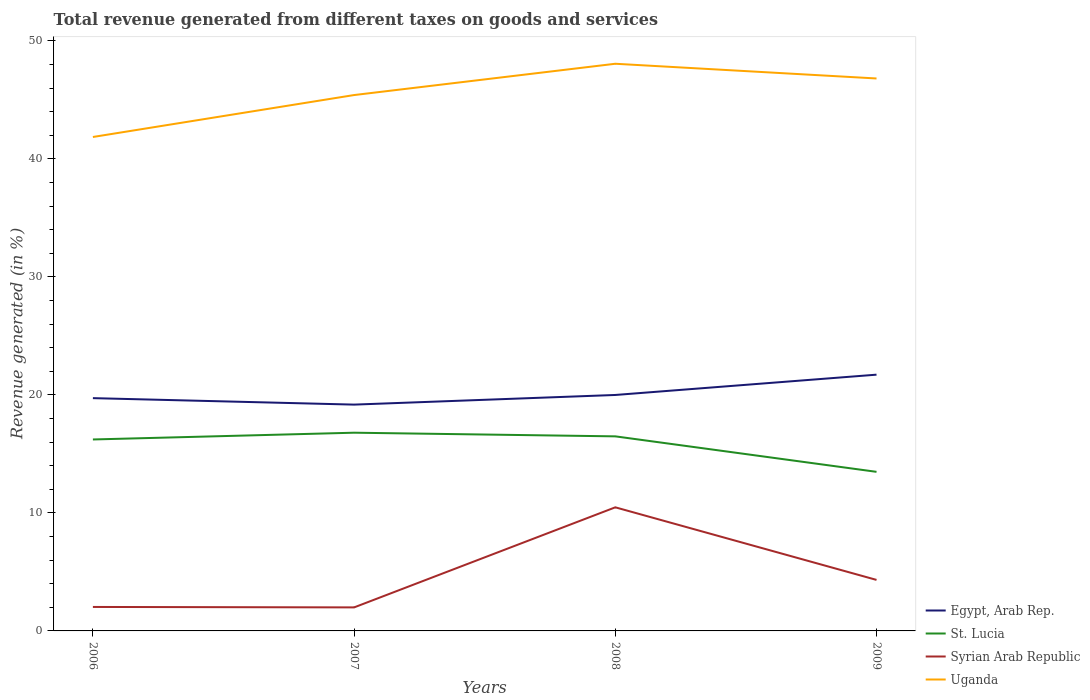Does the line corresponding to Uganda intersect with the line corresponding to Egypt, Arab Rep.?
Offer a terse response. No. Is the number of lines equal to the number of legend labels?
Your response must be concise. Yes. Across all years, what is the maximum total revenue generated in Syrian Arab Republic?
Make the answer very short. 1.99. In which year was the total revenue generated in Syrian Arab Republic maximum?
Give a very brief answer. 2007. What is the total total revenue generated in Syrian Arab Republic in the graph?
Provide a short and direct response. -8.48. What is the difference between the highest and the second highest total revenue generated in Egypt, Arab Rep.?
Make the answer very short. 2.54. What is the difference between the highest and the lowest total revenue generated in St. Lucia?
Ensure brevity in your answer.  3. How many lines are there?
Your response must be concise. 4. How many years are there in the graph?
Offer a terse response. 4. Does the graph contain any zero values?
Ensure brevity in your answer.  No. Where does the legend appear in the graph?
Give a very brief answer. Bottom right. How many legend labels are there?
Make the answer very short. 4. How are the legend labels stacked?
Your response must be concise. Vertical. What is the title of the graph?
Your answer should be very brief. Total revenue generated from different taxes on goods and services. Does "Hungary" appear as one of the legend labels in the graph?
Your answer should be compact. No. What is the label or title of the X-axis?
Provide a succinct answer. Years. What is the label or title of the Y-axis?
Provide a succinct answer. Revenue generated (in %). What is the Revenue generated (in %) of Egypt, Arab Rep. in 2006?
Ensure brevity in your answer.  19.72. What is the Revenue generated (in %) in St. Lucia in 2006?
Your response must be concise. 16.22. What is the Revenue generated (in %) in Syrian Arab Republic in 2006?
Provide a short and direct response. 2.03. What is the Revenue generated (in %) of Uganda in 2006?
Keep it short and to the point. 41.85. What is the Revenue generated (in %) in Egypt, Arab Rep. in 2007?
Offer a terse response. 19.18. What is the Revenue generated (in %) in St. Lucia in 2007?
Give a very brief answer. 16.8. What is the Revenue generated (in %) in Syrian Arab Republic in 2007?
Make the answer very short. 1.99. What is the Revenue generated (in %) of Uganda in 2007?
Make the answer very short. 45.4. What is the Revenue generated (in %) in Egypt, Arab Rep. in 2008?
Provide a succinct answer. 19.99. What is the Revenue generated (in %) of St. Lucia in 2008?
Your response must be concise. 16.49. What is the Revenue generated (in %) in Syrian Arab Republic in 2008?
Your answer should be compact. 10.47. What is the Revenue generated (in %) of Uganda in 2008?
Offer a very short reply. 48.06. What is the Revenue generated (in %) of Egypt, Arab Rep. in 2009?
Provide a succinct answer. 21.71. What is the Revenue generated (in %) of St. Lucia in 2009?
Provide a succinct answer. 13.48. What is the Revenue generated (in %) in Syrian Arab Republic in 2009?
Give a very brief answer. 4.32. What is the Revenue generated (in %) of Uganda in 2009?
Keep it short and to the point. 46.81. Across all years, what is the maximum Revenue generated (in %) in Egypt, Arab Rep.?
Provide a succinct answer. 21.71. Across all years, what is the maximum Revenue generated (in %) of St. Lucia?
Your answer should be compact. 16.8. Across all years, what is the maximum Revenue generated (in %) in Syrian Arab Republic?
Your answer should be very brief. 10.47. Across all years, what is the maximum Revenue generated (in %) in Uganda?
Ensure brevity in your answer.  48.06. Across all years, what is the minimum Revenue generated (in %) in Egypt, Arab Rep.?
Offer a very short reply. 19.18. Across all years, what is the minimum Revenue generated (in %) in St. Lucia?
Give a very brief answer. 13.48. Across all years, what is the minimum Revenue generated (in %) of Syrian Arab Republic?
Ensure brevity in your answer.  1.99. Across all years, what is the minimum Revenue generated (in %) of Uganda?
Provide a succinct answer. 41.85. What is the total Revenue generated (in %) of Egypt, Arab Rep. in the graph?
Your answer should be compact. 80.6. What is the total Revenue generated (in %) in St. Lucia in the graph?
Offer a terse response. 62.98. What is the total Revenue generated (in %) in Syrian Arab Republic in the graph?
Your answer should be very brief. 18.82. What is the total Revenue generated (in %) in Uganda in the graph?
Provide a succinct answer. 182.12. What is the difference between the Revenue generated (in %) in Egypt, Arab Rep. in 2006 and that in 2007?
Offer a terse response. 0.55. What is the difference between the Revenue generated (in %) of St. Lucia in 2006 and that in 2007?
Your answer should be very brief. -0.57. What is the difference between the Revenue generated (in %) of Syrian Arab Republic in 2006 and that in 2007?
Keep it short and to the point. 0.04. What is the difference between the Revenue generated (in %) of Uganda in 2006 and that in 2007?
Offer a terse response. -3.55. What is the difference between the Revenue generated (in %) of Egypt, Arab Rep. in 2006 and that in 2008?
Give a very brief answer. -0.27. What is the difference between the Revenue generated (in %) of St. Lucia in 2006 and that in 2008?
Provide a succinct answer. -0.26. What is the difference between the Revenue generated (in %) in Syrian Arab Republic in 2006 and that in 2008?
Make the answer very short. -8.44. What is the difference between the Revenue generated (in %) of Uganda in 2006 and that in 2008?
Your answer should be very brief. -6.2. What is the difference between the Revenue generated (in %) in Egypt, Arab Rep. in 2006 and that in 2009?
Give a very brief answer. -1.99. What is the difference between the Revenue generated (in %) in St. Lucia in 2006 and that in 2009?
Provide a short and direct response. 2.74. What is the difference between the Revenue generated (in %) in Syrian Arab Republic in 2006 and that in 2009?
Provide a short and direct response. -2.29. What is the difference between the Revenue generated (in %) of Uganda in 2006 and that in 2009?
Make the answer very short. -4.96. What is the difference between the Revenue generated (in %) of Egypt, Arab Rep. in 2007 and that in 2008?
Give a very brief answer. -0.82. What is the difference between the Revenue generated (in %) of St. Lucia in 2007 and that in 2008?
Provide a succinct answer. 0.31. What is the difference between the Revenue generated (in %) in Syrian Arab Republic in 2007 and that in 2008?
Make the answer very short. -8.48. What is the difference between the Revenue generated (in %) of Uganda in 2007 and that in 2008?
Offer a terse response. -2.65. What is the difference between the Revenue generated (in %) in Egypt, Arab Rep. in 2007 and that in 2009?
Provide a short and direct response. -2.54. What is the difference between the Revenue generated (in %) of St. Lucia in 2007 and that in 2009?
Offer a very short reply. 3.32. What is the difference between the Revenue generated (in %) of Syrian Arab Republic in 2007 and that in 2009?
Provide a short and direct response. -2.33. What is the difference between the Revenue generated (in %) in Uganda in 2007 and that in 2009?
Provide a short and direct response. -1.4. What is the difference between the Revenue generated (in %) in Egypt, Arab Rep. in 2008 and that in 2009?
Your answer should be compact. -1.72. What is the difference between the Revenue generated (in %) in St. Lucia in 2008 and that in 2009?
Keep it short and to the point. 3.01. What is the difference between the Revenue generated (in %) of Syrian Arab Republic in 2008 and that in 2009?
Your response must be concise. 6.15. What is the difference between the Revenue generated (in %) in Uganda in 2008 and that in 2009?
Make the answer very short. 1.25. What is the difference between the Revenue generated (in %) of Egypt, Arab Rep. in 2006 and the Revenue generated (in %) of St. Lucia in 2007?
Give a very brief answer. 2.93. What is the difference between the Revenue generated (in %) of Egypt, Arab Rep. in 2006 and the Revenue generated (in %) of Syrian Arab Republic in 2007?
Offer a terse response. 17.73. What is the difference between the Revenue generated (in %) in Egypt, Arab Rep. in 2006 and the Revenue generated (in %) in Uganda in 2007?
Provide a short and direct response. -25.68. What is the difference between the Revenue generated (in %) of St. Lucia in 2006 and the Revenue generated (in %) of Syrian Arab Republic in 2007?
Make the answer very short. 14.23. What is the difference between the Revenue generated (in %) of St. Lucia in 2006 and the Revenue generated (in %) of Uganda in 2007?
Your answer should be very brief. -29.18. What is the difference between the Revenue generated (in %) in Syrian Arab Republic in 2006 and the Revenue generated (in %) in Uganda in 2007?
Offer a terse response. -43.37. What is the difference between the Revenue generated (in %) in Egypt, Arab Rep. in 2006 and the Revenue generated (in %) in St. Lucia in 2008?
Provide a succinct answer. 3.24. What is the difference between the Revenue generated (in %) of Egypt, Arab Rep. in 2006 and the Revenue generated (in %) of Syrian Arab Republic in 2008?
Your answer should be very brief. 9.25. What is the difference between the Revenue generated (in %) of Egypt, Arab Rep. in 2006 and the Revenue generated (in %) of Uganda in 2008?
Provide a short and direct response. -28.33. What is the difference between the Revenue generated (in %) in St. Lucia in 2006 and the Revenue generated (in %) in Syrian Arab Republic in 2008?
Offer a very short reply. 5.75. What is the difference between the Revenue generated (in %) in St. Lucia in 2006 and the Revenue generated (in %) in Uganda in 2008?
Your response must be concise. -31.83. What is the difference between the Revenue generated (in %) in Syrian Arab Republic in 2006 and the Revenue generated (in %) in Uganda in 2008?
Your answer should be compact. -46.02. What is the difference between the Revenue generated (in %) in Egypt, Arab Rep. in 2006 and the Revenue generated (in %) in St. Lucia in 2009?
Ensure brevity in your answer.  6.24. What is the difference between the Revenue generated (in %) of Egypt, Arab Rep. in 2006 and the Revenue generated (in %) of Syrian Arab Republic in 2009?
Offer a very short reply. 15.4. What is the difference between the Revenue generated (in %) of Egypt, Arab Rep. in 2006 and the Revenue generated (in %) of Uganda in 2009?
Make the answer very short. -27.09. What is the difference between the Revenue generated (in %) in St. Lucia in 2006 and the Revenue generated (in %) in Syrian Arab Republic in 2009?
Your answer should be very brief. 11.9. What is the difference between the Revenue generated (in %) in St. Lucia in 2006 and the Revenue generated (in %) in Uganda in 2009?
Your answer should be very brief. -30.59. What is the difference between the Revenue generated (in %) in Syrian Arab Republic in 2006 and the Revenue generated (in %) in Uganda in 2009?
Your response must be concise. -44.78. What is the difference between the Revenue generated (in %) in Egypt, Arab Rep. in 2007 and the Revenue generated (in %) in St. Lucia in 2008?
Ensure brevity in your answer.  2.69. What is the difference between the Revenue generated (in %) of Egypt, Arab Rep. in 2007 and the Revenue generated (in %) of Syrian Arab Republic in 2008?
Ensure brevity in your answer.  8.7. What is the difference between the Revenue generated (in %) of Egypt, Arab Rep. in 2007 and the Revenue generated (in %) of Uganda in 2008?
Give a very brief answer. -28.88. What is the difference between the Revenue generated (in %) of St. Lucia in 2007 and the Revenue generated (in %) of Syrian Arab Republic in 2008?
Give a very brief answer. 6.32. What is the difference between the Revenue generated (in %) in St. Lucia in 2007 and the Revenue generated (in %) in Uganda in 2008?
Your response must be concise. -31.26. What is the difference between the Revenue generated (in %) of Syrian Arab Republic in 2007 and the Revenue generated (in %) of Uganda in 2008?
Your answer should be compact. -46.06. What is the difference between the Revenue generated (in %) in Egypt, Arab Rep. in 2007 and the Revenue generated (in %) in St. Lucia in 2009?
Make the answer very short. 5.7. What is the difference between the Revenue generated (in %) in Egypt, Arab Rep. in 2007 and the Revenue generated (in %) in Syrian Arab Republic in 2009?
Offer a terse response. 14.85. What is the difference between the Revenue generated (in %) in Egypt, Arab Rep. in 2007 and the Revenue generated (in %) in Uganda in 2009?
Your response must be concise. -27.63. What is the difference between the Revenue generated (in %) of St. Lucia in 2007 and the Revenue generated (in %) of Syrian Arab Republic in 2009?
Ensure brevity in your answer.  12.47. What is the difference between the Revenue generated (in %) of St. Lucia in 2007 and the Revenue generated (in %) of Uganda in 2009?
Make the answer very short. -30.01. What is the difference between the Revenue generated (in %) in Syrian Arab Republic in 2007 and the Revenue generated (in %) in Uganda in 2009?
Offer a terse response. -44.82. What is the difference between the Revenue generated (in %) of Egypt, Arab Rep. in 2008 and the Revenue generated (in %) of St. Lucia in 2009?
Provide a short and direct response. 6.51. What is the difference between the Revenue generated (in %) in Egypt, Arab Rep. in 2008 and the Revenue generated (in %) in Syrian Arab Republic in 2009?
Ensure brevity in your answer.  15.67. What is the difference between the Revenue generated (in %) in Egypt, Arab Rep. in 2008 and the Revenue generated (in %) in Uganda in 2009?
Ensure brevity in your answer.  -26.82. What is the difference between the Revenue generated (in %) in St. Lucia in 2008 and the Revenue generated (in %) in Syrian Arab Republic in 2009?
Offer a terse response. 12.16. What is the difference between the Revenue generated (in %) of St. Lucia in 2008 and the Revenue generated (in %) of Uganda in 2009?
Keep it short and to the point. -30.32. What is the difference between the Revenue generated (in %) of Syrian Arab Republic in 2008 and the Revenue generated (in %) of Uganda in 2009?
Offer a very short reply. -36.34. What is the average Revenue generated (in %) in Egypt, Arab Rep. per year?
Provide a short and direct response. 20.15. What is the average Revenue generated (in %) in St. Lucia per year?
Offer a very short reply. 15.75. What is the average Revenue generated (in %) of Syrian Arab Republic per year?
Offer a terse response. 4.7. What is the average Revenue generated (in %) of Uganda per year?
Offer a very short reply. 45.53. In the year 2006, what is the difference between the Revenue generated (in %) in Egypt, Arab Rep. and Revenue generated (in %) in St. Lucia?
Offer a very short reply. 3.5. In the year 2006, what is the difference between the Revenue generated (in %) in Egypt, Arab Rep. and Revenue generated (in %) in Syrian Arab Republic?
Keep it short and to the point. 17.69. In the year 2006, what is the difference between the Revenue generated (in %) of Egypt, Arab Rep. and Revenue generated (in %) of Uganda?
Provide a succinct answer. -22.13. In the year 2006, what is the difference between the Revenue generated (in %) of St. Lucia and Revenue generated (in %) of Syrian Arab Republic?
Provide a succinct answer. 14.19. In the year 2006, what is the difference between the Revenue generated (in %) of St. Lucia and Revenue generated (in %) of Uganda?
Offer a very short reply. -25.63. In the year 2006, what is the difference between the Revenue generated (in %) of Syrian Arab Republic and Revenue generated (in %) of Uganda?
Your response must be concise. -39.82. In the year 2007, what is the difference between the Revenue generated (in %) in Egypt, Arab Rep. and Revenue generated (in %) in St. Lucia?
Keep it short and to the point. 2.38. In the year 2007, what is the difference between the Revenue generated (in %) in Egypt, Arab Rep. and Revenue generated (in %) in Syrian Arab Republic?
Offer a very short reply. 17.18. In the year 2007, what is the difference between the Revenue generated (in %) in Egypt, Arab Rep. and Revenue generated (in %) in Uganda?
Give a very brief answer. -26.23. In the year 2007, what is the difference between the Revenue generated (in %) of St. Lucia and Revenue generated (in %) of Syrian Arab Republic?
Ensure brevity in your answer.  14.8. In the year 2007, what is the difference between the Revenue generated (in %) of St. Lucia and Revenue generated (in %) of Uganda?
Provide a short and direct response. -28.61. In the year 2007, what is the difference between the Revenue generated (in %) in Syrian Arab Republic and Revenue generated (in %) in Uganda?
Offer a terse response. -43.41. In the year 2008, what is the difference between the Revenue generated (in %) of Egypt, Arab Rep. and Revenue generated (in %) of St. Lucia?
Your response must be concise. 3.51. In the year 2008, what is the difference between the Revenue generated (in %) in Egypt, Arab Rep. and Revenue generated (in %) in Syrian Arab Republic?
Provide a short and direct response. 9.52. In the year 2008, what is the difference between the Revenue generated (in %) of Egypt, Arab Rep. and Revenue generated (in %) of Uganda?
Give a very brief answer. -28.06. In the year 2008, what is the difference between the Revenue generated (in %) in St. Lucia and Revenue generated (in %) in Syrian Arab Republic?
Make the answer very short. 6.01. In the year 2008, what is the difference between the Revenue generated (in %) in St. Lucia and Revenue generated (in %) in Uganda?
Your response must be concise. -31.57. In the year 2008, what is the difference between the Revenue generated (in %) in Syrian Arab Republic and Revenue generated (in %) in Uganda?
Keep it short and to the point. -37.58. In the year 2009, what is the difference between the Revenue generated (in %) in Egypt, Arab Rep. and Revenue generated (in %) in St. Lucia?
Your answer should be very brief. 8.23. In the year 2009, what is the difference between the Revenue generated (in %) in Egypt, Arab Rep. and Revenue generated (in %) in Syrian Arab Republic?
Ensure brevity in your answer.  17.39. In the year 2009, what is the difference between the Revenue generated (in %) of Egypt, Arab Rep. and Revenue generated (in %) of Uganda?
Offer a very short reply. -25.1. In the year 2009, what is the difference between the Revenue generated (in %) of St. Lucia and Revenue generated (in %) of Syrian Arab Republic?
Make the answer very short. 9.16. In the year 2009, what is the difference between the Revenue generated (in %) in St. Lucia and Revenue generated (in %) in Uganda?
Your answer should be very brief. -33.33. In the year 2009, what is the difference between the Revenue generated (in %) in Syrian Arab Republic and Revenue generated (in %) in Uganda?
Keep it short and to the point. -42.49. What is the ratio of the Revenue generated (in %) of Egypt, Arab Rep. in 2006 to that in 2007?
Make the answer very short. 1.03. What is the ratio of the Revenue generated (in %) in St. Lucia in 2006 to that in 2007?
Provide a succinct answer. 0.97. What is the ratio of the Revenue generated (in %) in Uganda in 2006 to that in 2007?
Give a very brief answer. 0.92. What is the ratio of the Revenue generated (in %) of Egypt, Arab Rep. in 2006 to that in 2008?
Keep it short and to the point. 0.99. What is the ratio of the Revenue generated (in %) in St. Lucia in 2006 to that in 2008?
Give a very brief answer. 0.98. What is the ratio of the Revenue generated (in %) in Syrian Arab Republic in 2006 to that in 2008?
Give a very brief answer. 0.19. What is the ratio of the Revenue generated (in %) in Uganda in 2006 to that in 2008?
Keep it short and to the point. 0.87. What is the ratio of the Revenue generated (in %) of Egypt, Arab Rep. in 2006 to that in 2009?
Make the answer very short. 0.91. What is the ratio of the Revenue generated (in %) of St. Lucia in 2006 to that in 2009?
Ensure brevity in your answer.  1.2. What is the ratio of the Revenue generated (in %) of Syrian Arab Republic in 2006 to that in 2009?
Provide a succinct answer. 0.47. What is the ratio of the Revenue generated (in %) of Uganda in 2006 to that in 2009?
Give a very brief answer. 0.89. What is the ratio of the Revenue generated (in %) in Egypt, Arab Rep. in 2007 to that in 2008?
Offer a terse response. 0.96. What is the ratio of the Revenue generated (in %) in St. Lucia in 2007 to that in 2008?
Keep it short and to the point. 1.02. What is the ratio of the Revenue generated (in %) in Syrian Arab Republic in 2007 to that in 2008?
Offer a terse response. 0.19. What is the ratio of the Revenue generated (in %) in Uganda in 2007 to that in 2008?
Your answer should be very brief. 0.94. What is the ratio of the Revenue generated (in %) in Egypt, Arab Rep. in 2007 to that in 2009?
Your answer should be very brief. 0.88. What is the ratio of the Revenue generated (in %) of St. Lucia in 2007 to that in 2009?
Offer a terse response. 1.25. What is the ratio of the Revenue generated (in %) in Syrian Arab Republic in 2007 to that in 2009?
Your answer should be very brief. 0.46. What is the ratio of the Revenue generated (in %) of Egypt, Arab Rep. in 2008 to that in 2009?
Provide a short and direct response. 0.92. What is the ratio of the Revenue generated (in %) of St. Lucia in 2008 to that in 2009?
Ensure brevity in your answer.  1.22. What is the ratio of the Revenue generated (in %) in Syrian Arab Republic in 2008 to that in 2009?
Provide a short and direct response. 2.42. What is the ratio of the Revenue generated (in %) in Uganda in 2008 to that in 2009?
Make the answer very short. 1.03. What is the difference between the highest and the second highest Revenue generated (in %) of Egypt, Arab Rep.?
Offer a terse response. 1.72. What is the difference between the highest and the second highest Revenue generated (in %) in St. Lucia?
Make the answer very short. 0.31. What is the difference between the highest and the second highest Revenue generated (in %) in Syrian Arab Republic?
Keep it short and to the point. 6.15. What is the difference between the highest and the second highest Revenue generated (in %) of Uganda?
Offer a very short reply. 1.25. What is the difference between the highest and the lowest Revenue generated (in %) of Egypt, Arab Rep.?
Make the answer very short. 2.54. What is the difference between the highest and the lowest Revenue generated (in %) of St. Lucia?
Provide a succinct answer. 3.32. What is the difference between the highest and the lowest Revenue generated (in %) of Syrian Arab Republic?
Your answer should be compact. 8.48. What is the difference between the highest and the lowest Revenue generated (in %) in Uganda?
Your response must be concise. 6.2. 